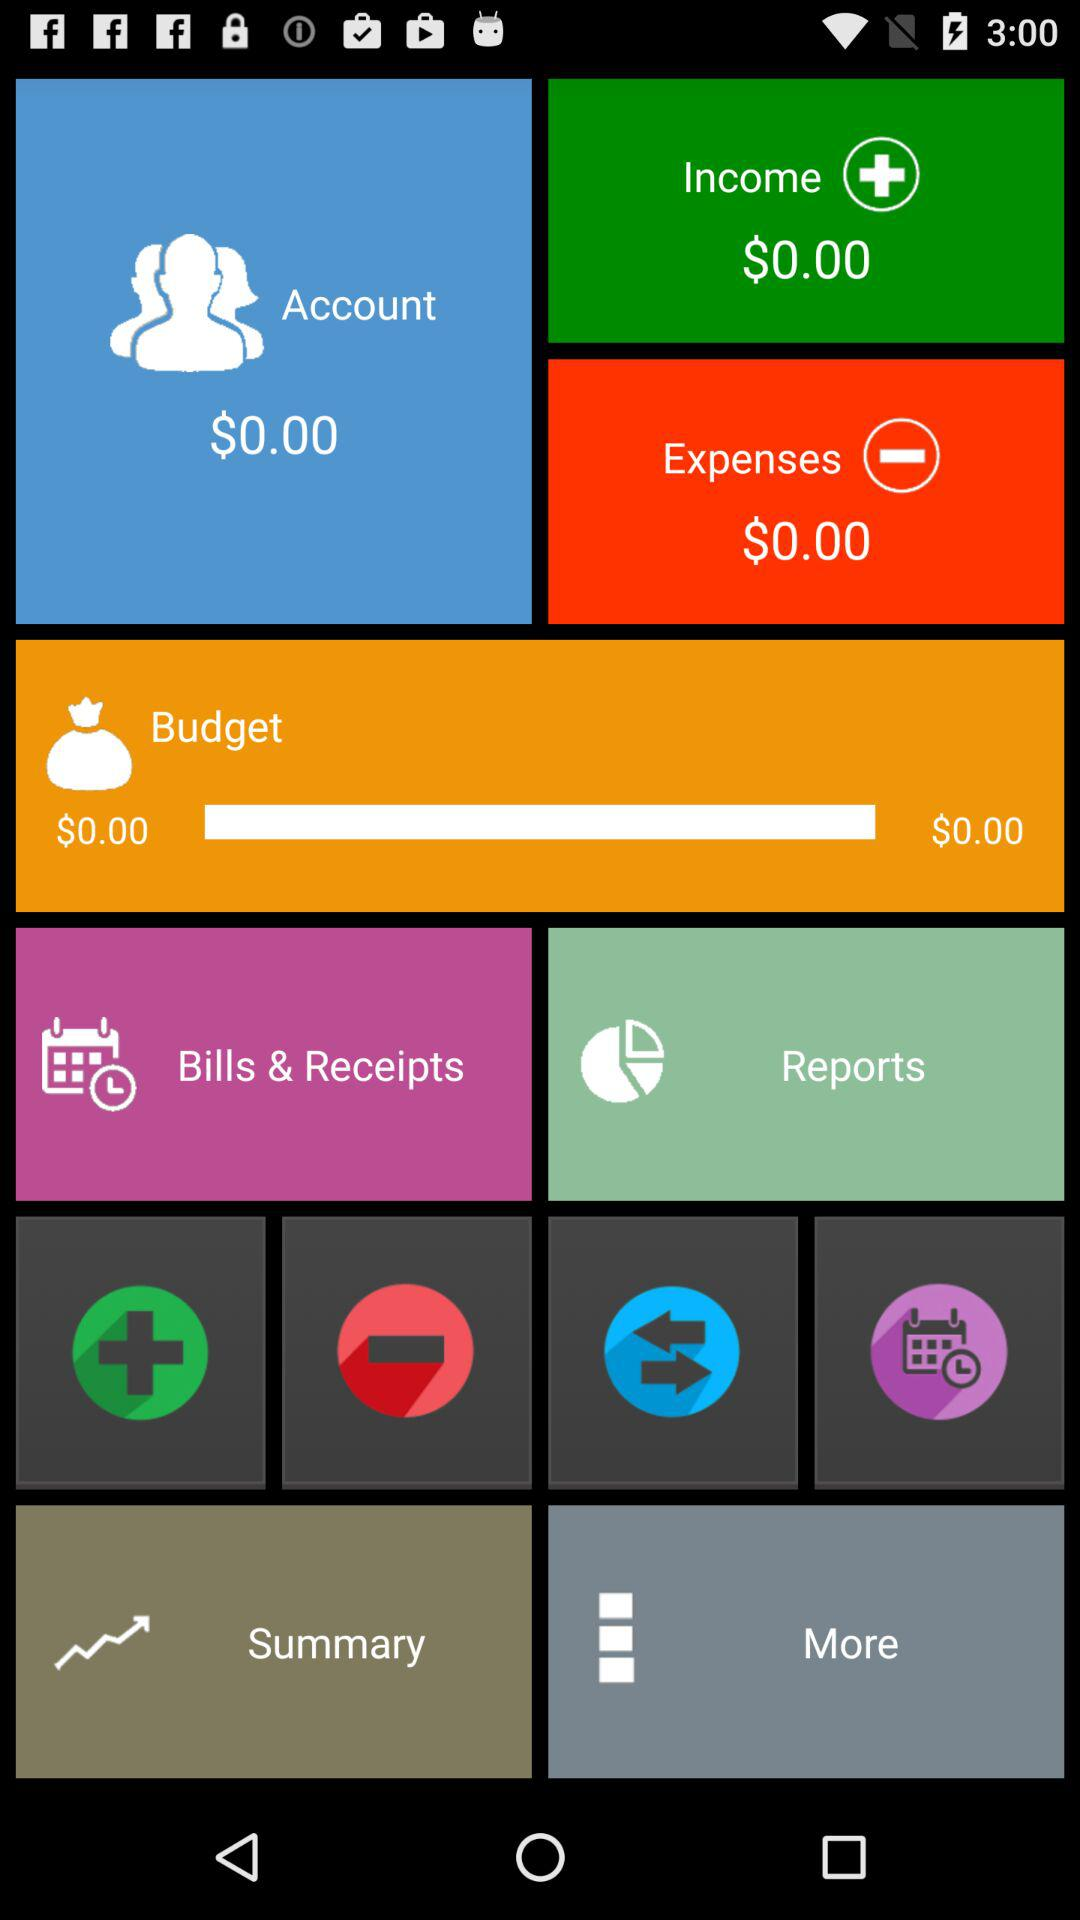What is the currency for the earned income? The currency for the earned income is dollars. 